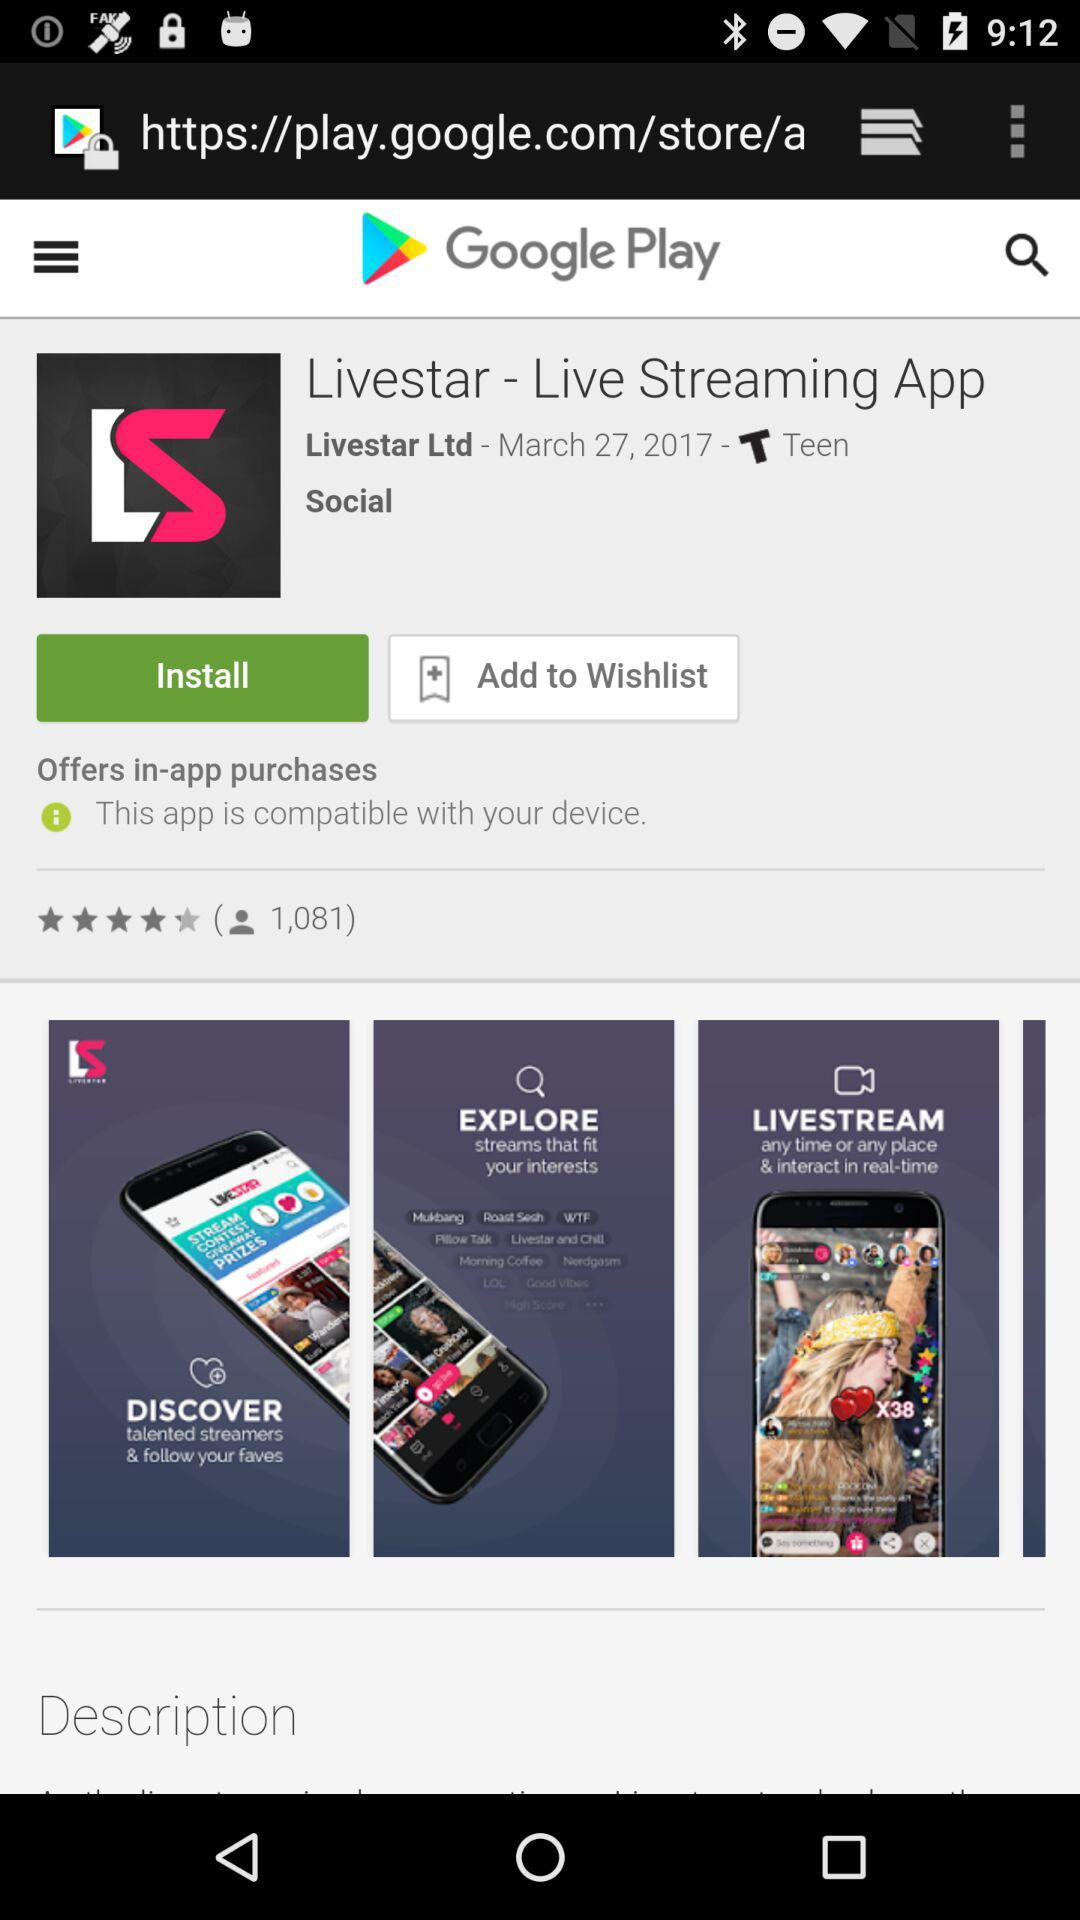What's the release date of the application? The release date of the application is March 27, 2017. 